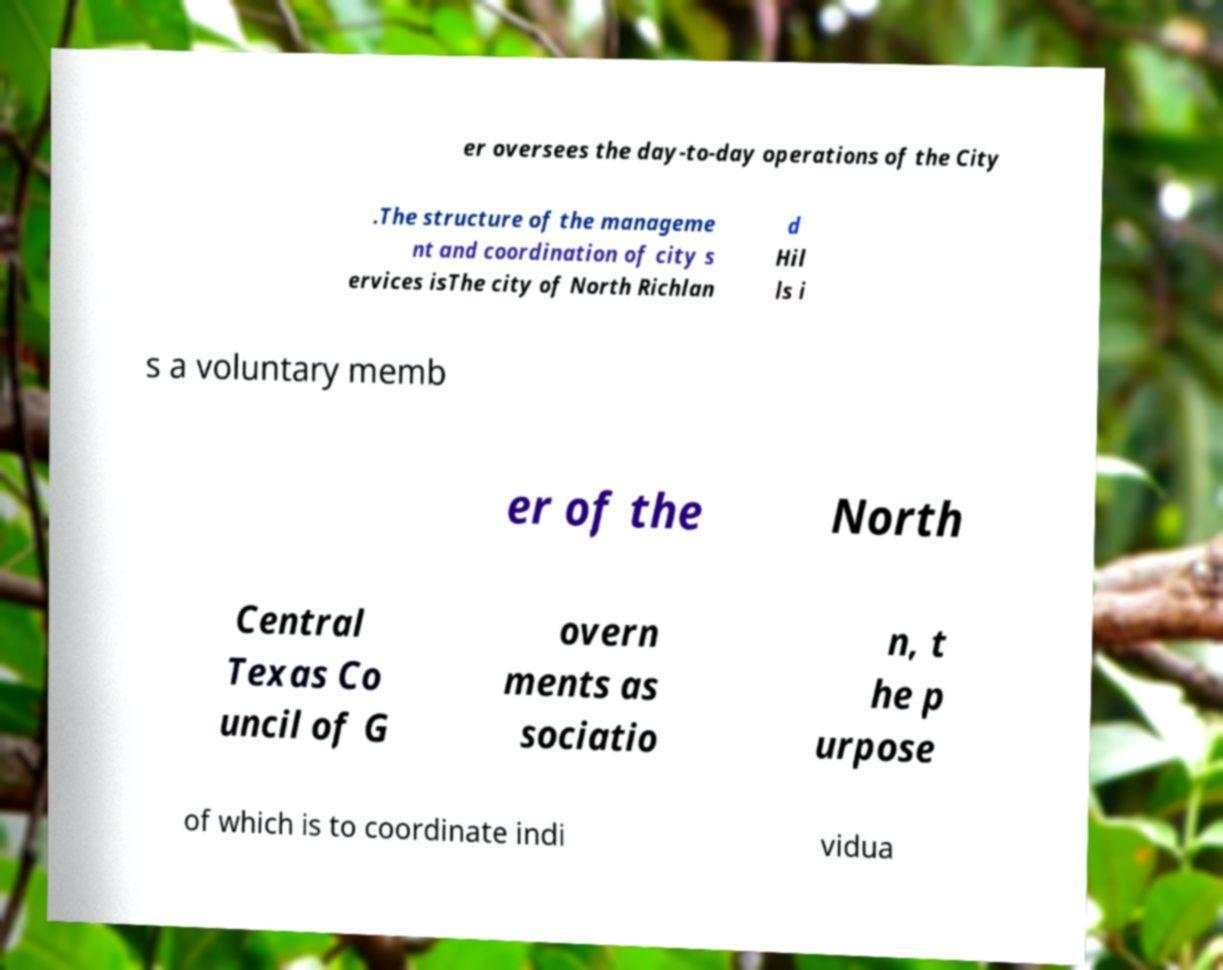There's text embedded in this image that I need extracted. Can you transcribe it verbatim? er oversees the day-to-day operations of the City .The structure of the manageme nt and coordination of city s ervices isThe city of North Richlan d Hil ls i s a voluntary memb er of the North Central Texas Co uncil of G overn ments as sociatio n, t he p urpose of which is to coordinate indi vidua 